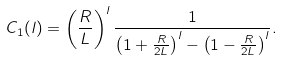<formula> <loc_0><loc_0><loc_500><loc_500>C _ { 1 } ( l ) = \left ( \frac { R } { L } \right ) ^ { l } \frac { 1 } { \left ( 1 + \frac { R } { 2 L } \right ) ^ { l } - \left ( 1 - \frac { R } { 2 L } \right ) ^ { l } } .</formula> 